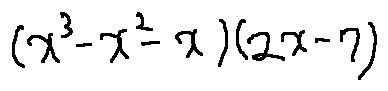<formula> <loc_0><loc_0><loc_500><loc_500>( x ^ { 3 } - x ^ { 2 } - x ) ( 2 x - 7 )</formula> 